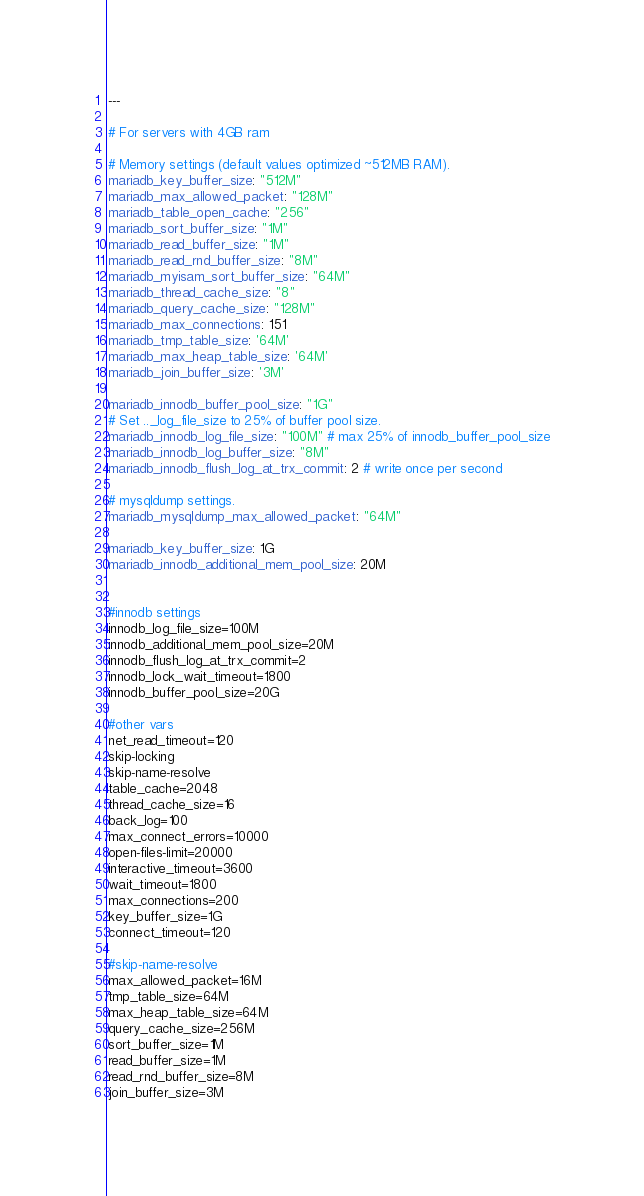<code> <loc_0><loc_0><loc_500><loc_500><_YAML_>---

# For servers with 4GB ram

# Memory settings (default values optimized ~512MB RAM).
mariadb_key_buffer_size: "512M"
mariadb_max_allowed_packet: "128M"
mariadb_table_open_cache: "256"
mariadb_sort_buffer_size: "1M"
mariadb_read_buffer_size: "1M"
mariadb_read_rnd_buffer_size: "8M"
mariadb_myisam_sort_buffer_size: "64M"
mariadb_thread_cache_size: "8"
mariadb_query_cache_size: "128M"
mariadb_max_connections: 151
mariadb_tmp_table_size: '64M'
mariadb_max_heap_table_size: '64M'
mariadb_join_buffer_size: '3M'

mariadb_innodb_buffer_pool_size: "1G"
# Set .._log_file_size to 25% of buffer pool size.
mariadb_innodb_log_file_size: "100M" # max 25% of innodb_buffer_pool_size
mariadb_innodb_log_buffer_size: "8M"
mariadb_innodb_flush_log_at_trx_commit: 2 # write once per second

# mysqldump settings.
mariadb_mysqldump_max_allowed_packet: "64M"

mariadb_key_buffer_size: 1G
mariadb_innodb_additional_mem_pool_size: 20M


#innodb settings
innodb_log_file_size=100M
innodb_additional_mem_pool_size=20M
innodb_flush_log_at_trx_commit=2
innodb_lock_wait_timeout=1800
innodb_buffer_pool_size=20G

#other vars
net_read_timeout=120
skip-locking
skip-name-resolve
table_cache=2048
thread_cache_size=16
back_log=100
max_connect_errors=10000
open-files-limit=20000
interactive_timeout=3600
wait_timeout=1800
max_connections=200
key_buffer_size=1G
connect_timeout=120

#skip-name-resolve
max_allowed_packet=16M
tmp_table_size=64M
max_heap_table_size=64M
query_cache_size=256M
sort_buffer_size=1M
read_buffer_size=1M
read_rnd_buffer_size=8M
join_buffer_size=3M</code> 